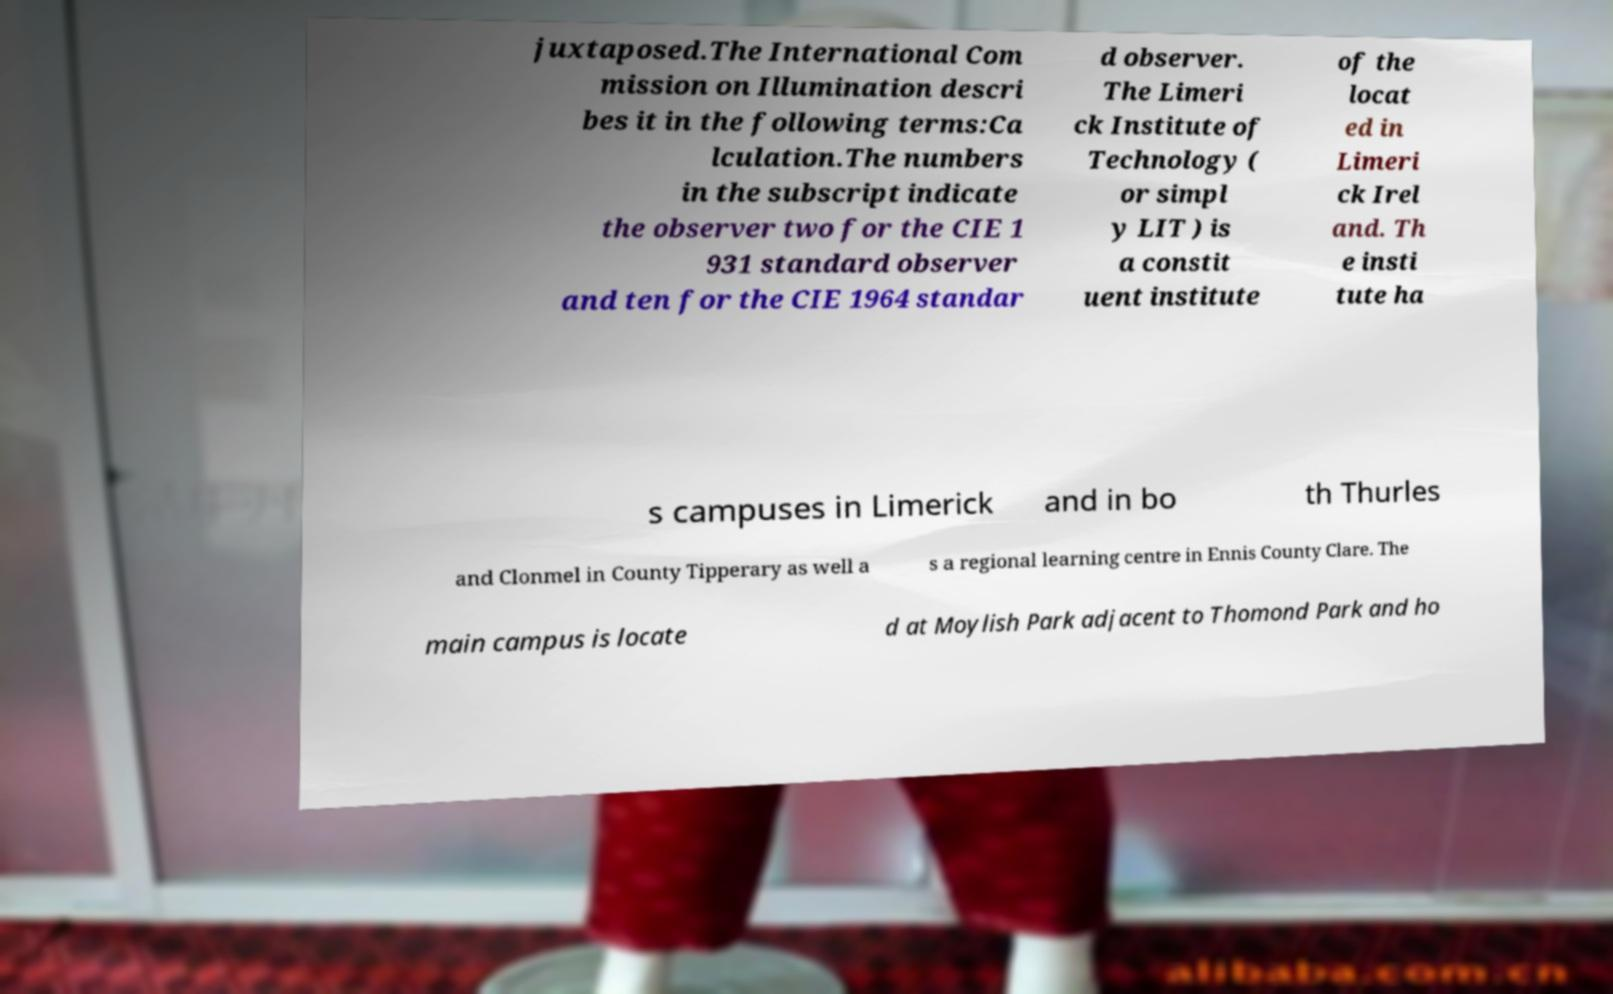I need the written content from this picture converted into text. Can you do that? juxtaposed.The International Com mission on Illumination descri bes it in the following terms:Ca lculation.The numbers in the subscript indicate the observer two for the CIE 1 931 standard observer and ten for the CIE 1964 standar d observer. The Limeri ck Institute of Technology ( or simpl y LIT ) is a constit uent institute of the locat ed in Limeri ck Irel and. Th e insti tute ha s campuses in Limerick and in bo th Thurles and Clonmel in County Tipperary as well a s a regional learning centre in Ennis County Clare. The main campus is locate d at Moylish Park adjacent to Thomond Park and ho 